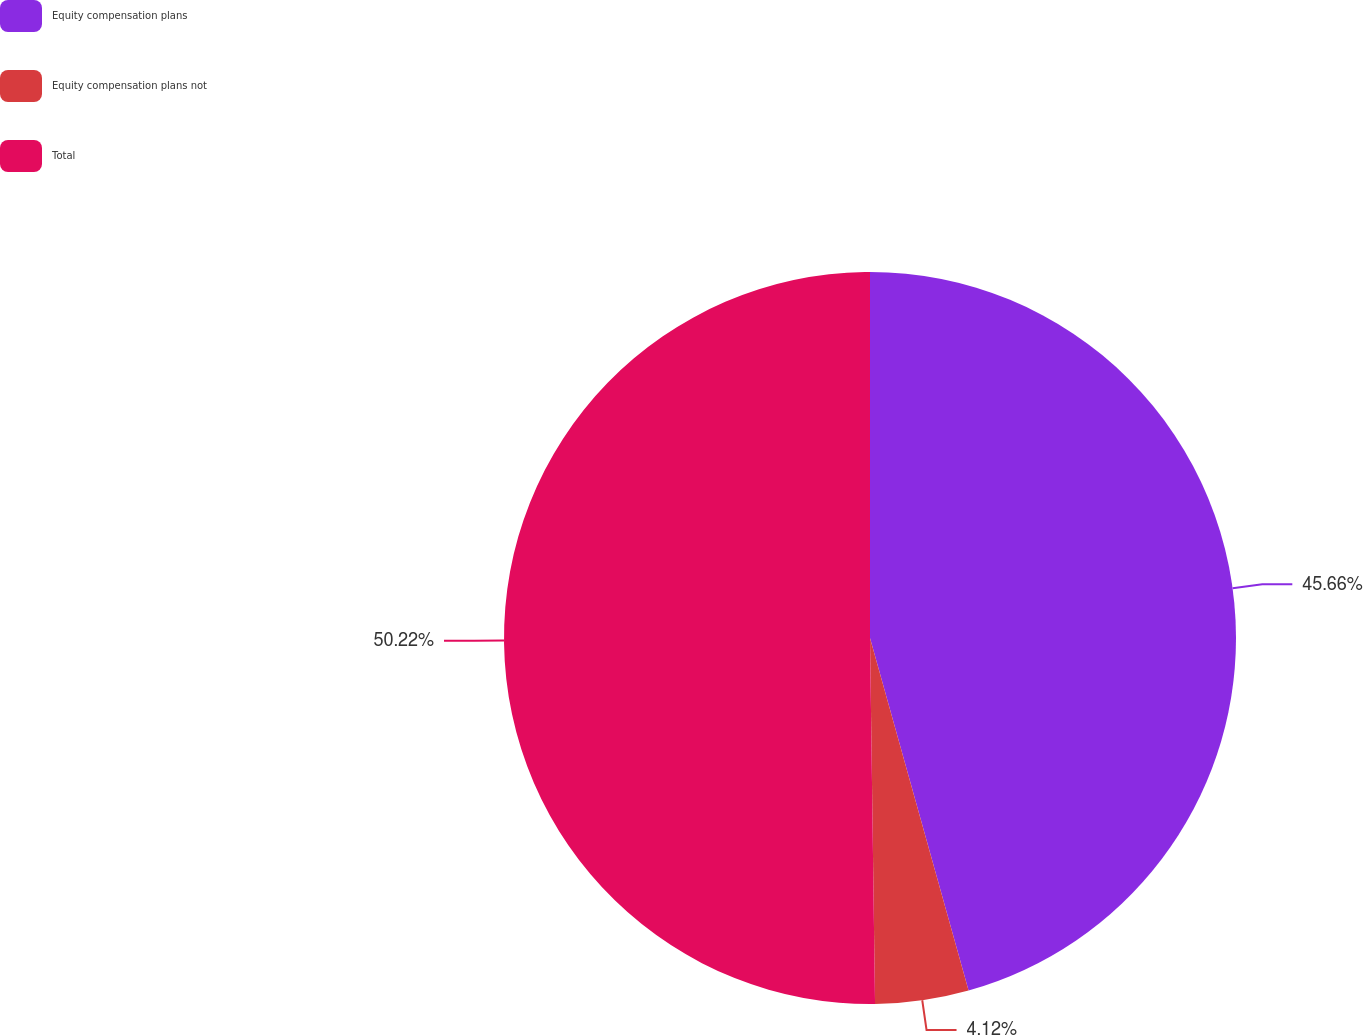<chart> <loc_0><loc_0><loc_500><loc_500><pie_chart><fcel>Equity compensation plans<fcel>Equity compensation plans not<fcel>Total<nl><fcel>45.66%<fcel>4.12%<fcel>50.22%<nl></chart> 